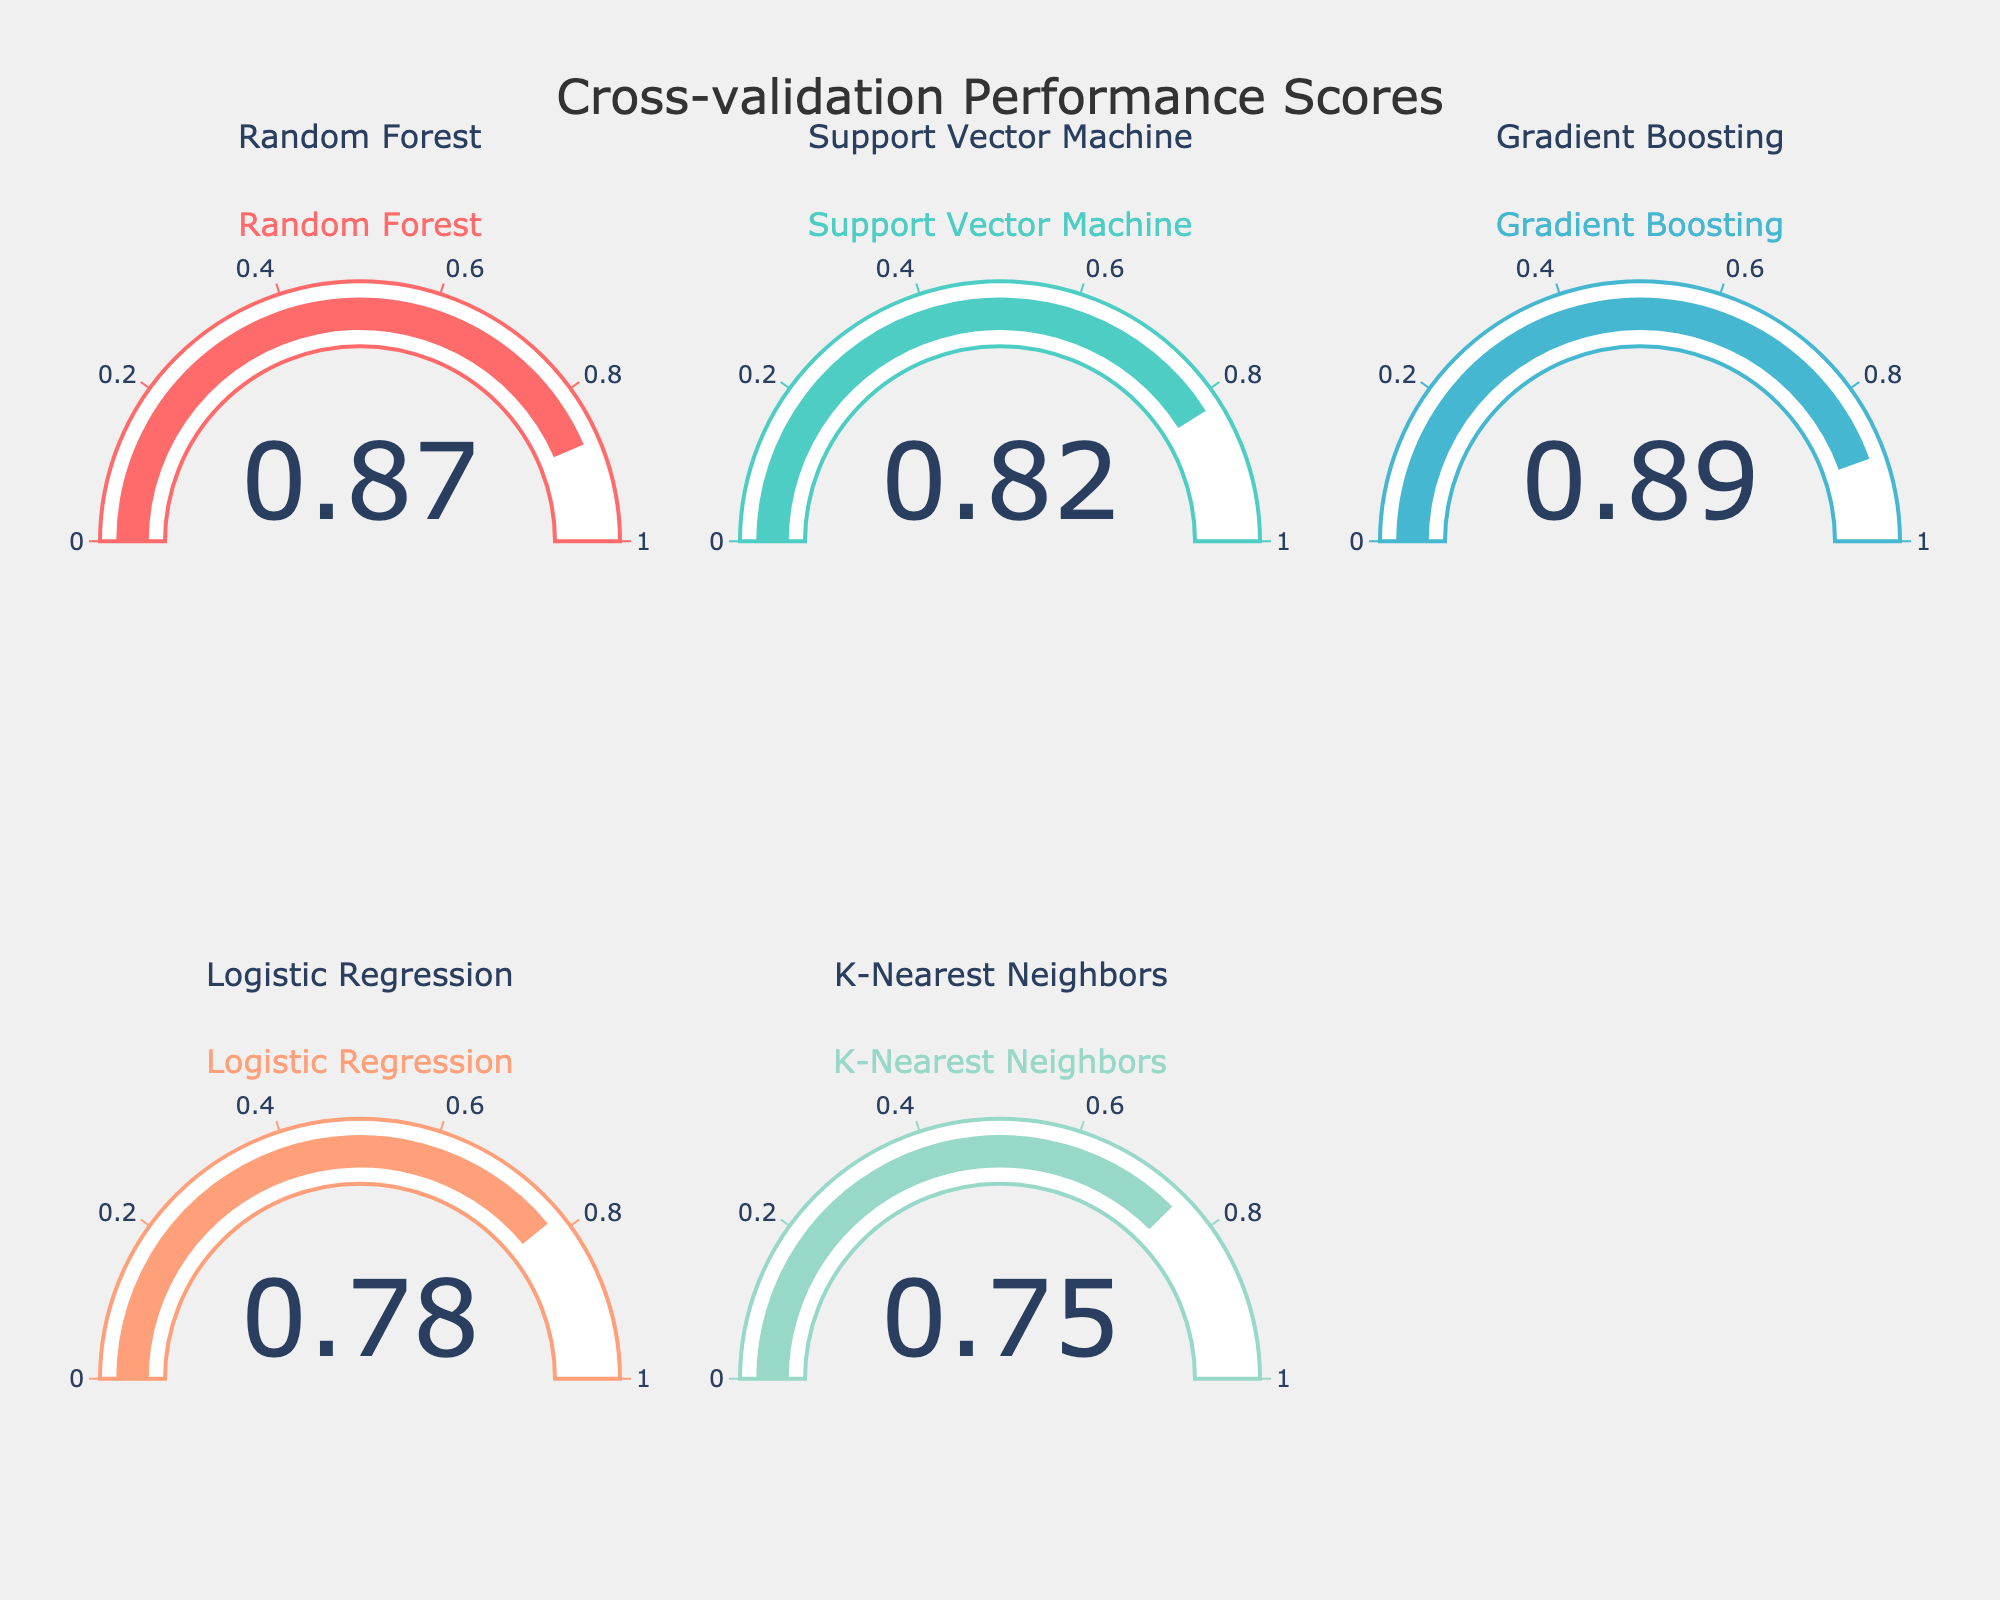Which model has the highest cross-validation score? The figure shows the cross-validation performance scores for several models. By inspecting the gauge values, Gradient Boosting has the highest value at 0.89.
Answer: Gradient Boosting Which model has the lowest cross-validation score? By looking at the figure, the K-Nearest Neighbors model shows the lowest score among all the models at 0.75.
Answer: K-Nearest Neighbors What is the range of the cross-validation scores displayed in the figure? The range of a set of values is obtained by subtracting the smallest value from the largest value. The highest score is 0.89 (Gradient Boosting) and the lowest is 0.75 (K-Nearest Neighbors). The range is 0.89 - 0.75 = 0.14.
Answer: 0.14 How many models have a cross-validation score greater than 0.8? By inspecting the values on the gauges, the models with scores greater than 0.8 are Random Forest (0.87), Support Vector Machine (0.82), and Gradient Boosting (0.89). There are 3 such models.
Answer: 3 What is the average cross-validation score of all the models? Sum the scores of all the models: 0.87 (Random Forest) + 0.82 (Support Vector Machine) + 0.89 (Gradient Boosting) + 0.78 (Logistic Regression) + 0.75 (K-Nearest Neighbors) = 4.11. Divide by the number of models (5): 4.11 / 5 = 0.822.
Answer: 0.822 Which models have a cross-validation score less than 0.8? By looking at the gauge values, the models with scores less than 0.8 are Logistic Regression (0.78) and K-Nearest Neighbors (0.75).
Answer: Logistic Regression and K-Nearest Neighbors What is the difference in cross-validation score between the Random Forest and the Logistic Regression models? From the gauge values, the Random Forest model has a score of 0.87, while the Logistic Regression has a score of 0.78. The difference is 0.87 - 0.78 = 0.09.
Answer: 0.09 Is the Support Vector Machine's cross-validation score closer to the Random Forest's score or to the Logistic Regression's score? The Support Vector Machine has a score of 0.82. The differences from the Random Forest (0.87) and Logistic Regression (0.78) are: 0.87 - 0.82 = 0.05 and 0.82 - 0.78 = 0.04, respectively. Since 0.04 is smaller than 0.05, it is closer to the Logistic Regression's score.
Answer: Logistic Regression 